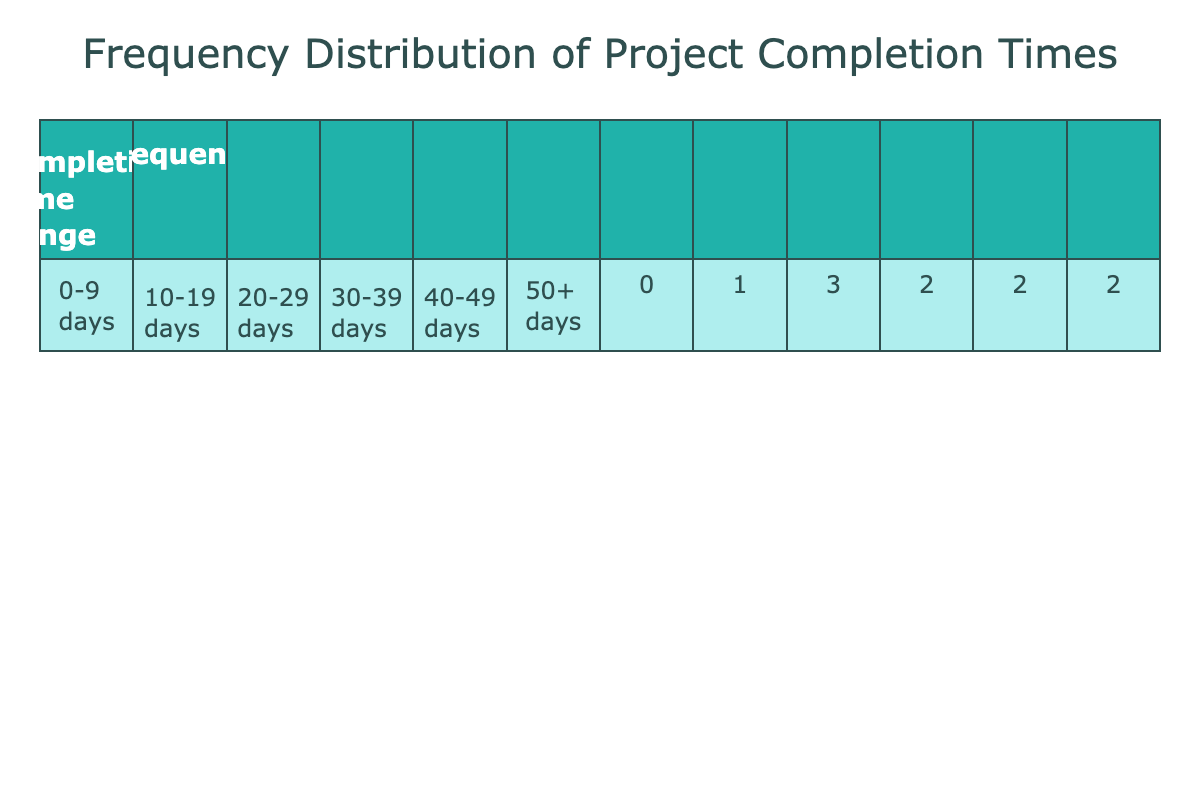What is the range with the highest frequency of project completion times? Looking at the frequency values in the table, the range with the highest frequency is 20-29 days, which has a frequency of 3.
Answer: 20-29 days How many projects took longer than 40 days to complete? From the frequency distribution, we see ranges above 40 days: 40-49 days has 2 projects and 50+ days has 1 project, totaling 3 projects.
Answer: 3 projects What is the total number of projects listed in the table? By counting all the unique project names in the table, there are 10 projects in total.
Answer: 10 Is there any project that took exactly 25 days to complete? Checking the completion times in the data, there is one project, "Mobile App Upgrade", that took exactly 25 days.
Answer: Yes What is the average completion time of all projects? To find the average, we sum the completion times (25 + 40 + 30 + 50 + 20 + 15 + 35 + 45 + 28 + 60 = 403) and divide by the number of projects (10), resulting in an average completion time of 40.3 days.
Answer: 40.3 days Which completion time range has the lowest frequency, and what is that frequency? Looking through the frequency table, the range with the lowest frequency is 10-19 days, with a frequency of 1.
Answer: 10-19 days, frequency 1 How many projects were completed in the range of 30-39 days? From the table, the range of 30-39 days has 3 projects (30-39 days, see counts of projects).
Answer: 3 projects What is the difference in frequency between the ranges of 30-39 days and 40-49 days? The 30-39 days range has a frequency of 3, while the 40-49 days range has a frequency of 2. The difference is 3 - 2 = 1.
Answer: 1 